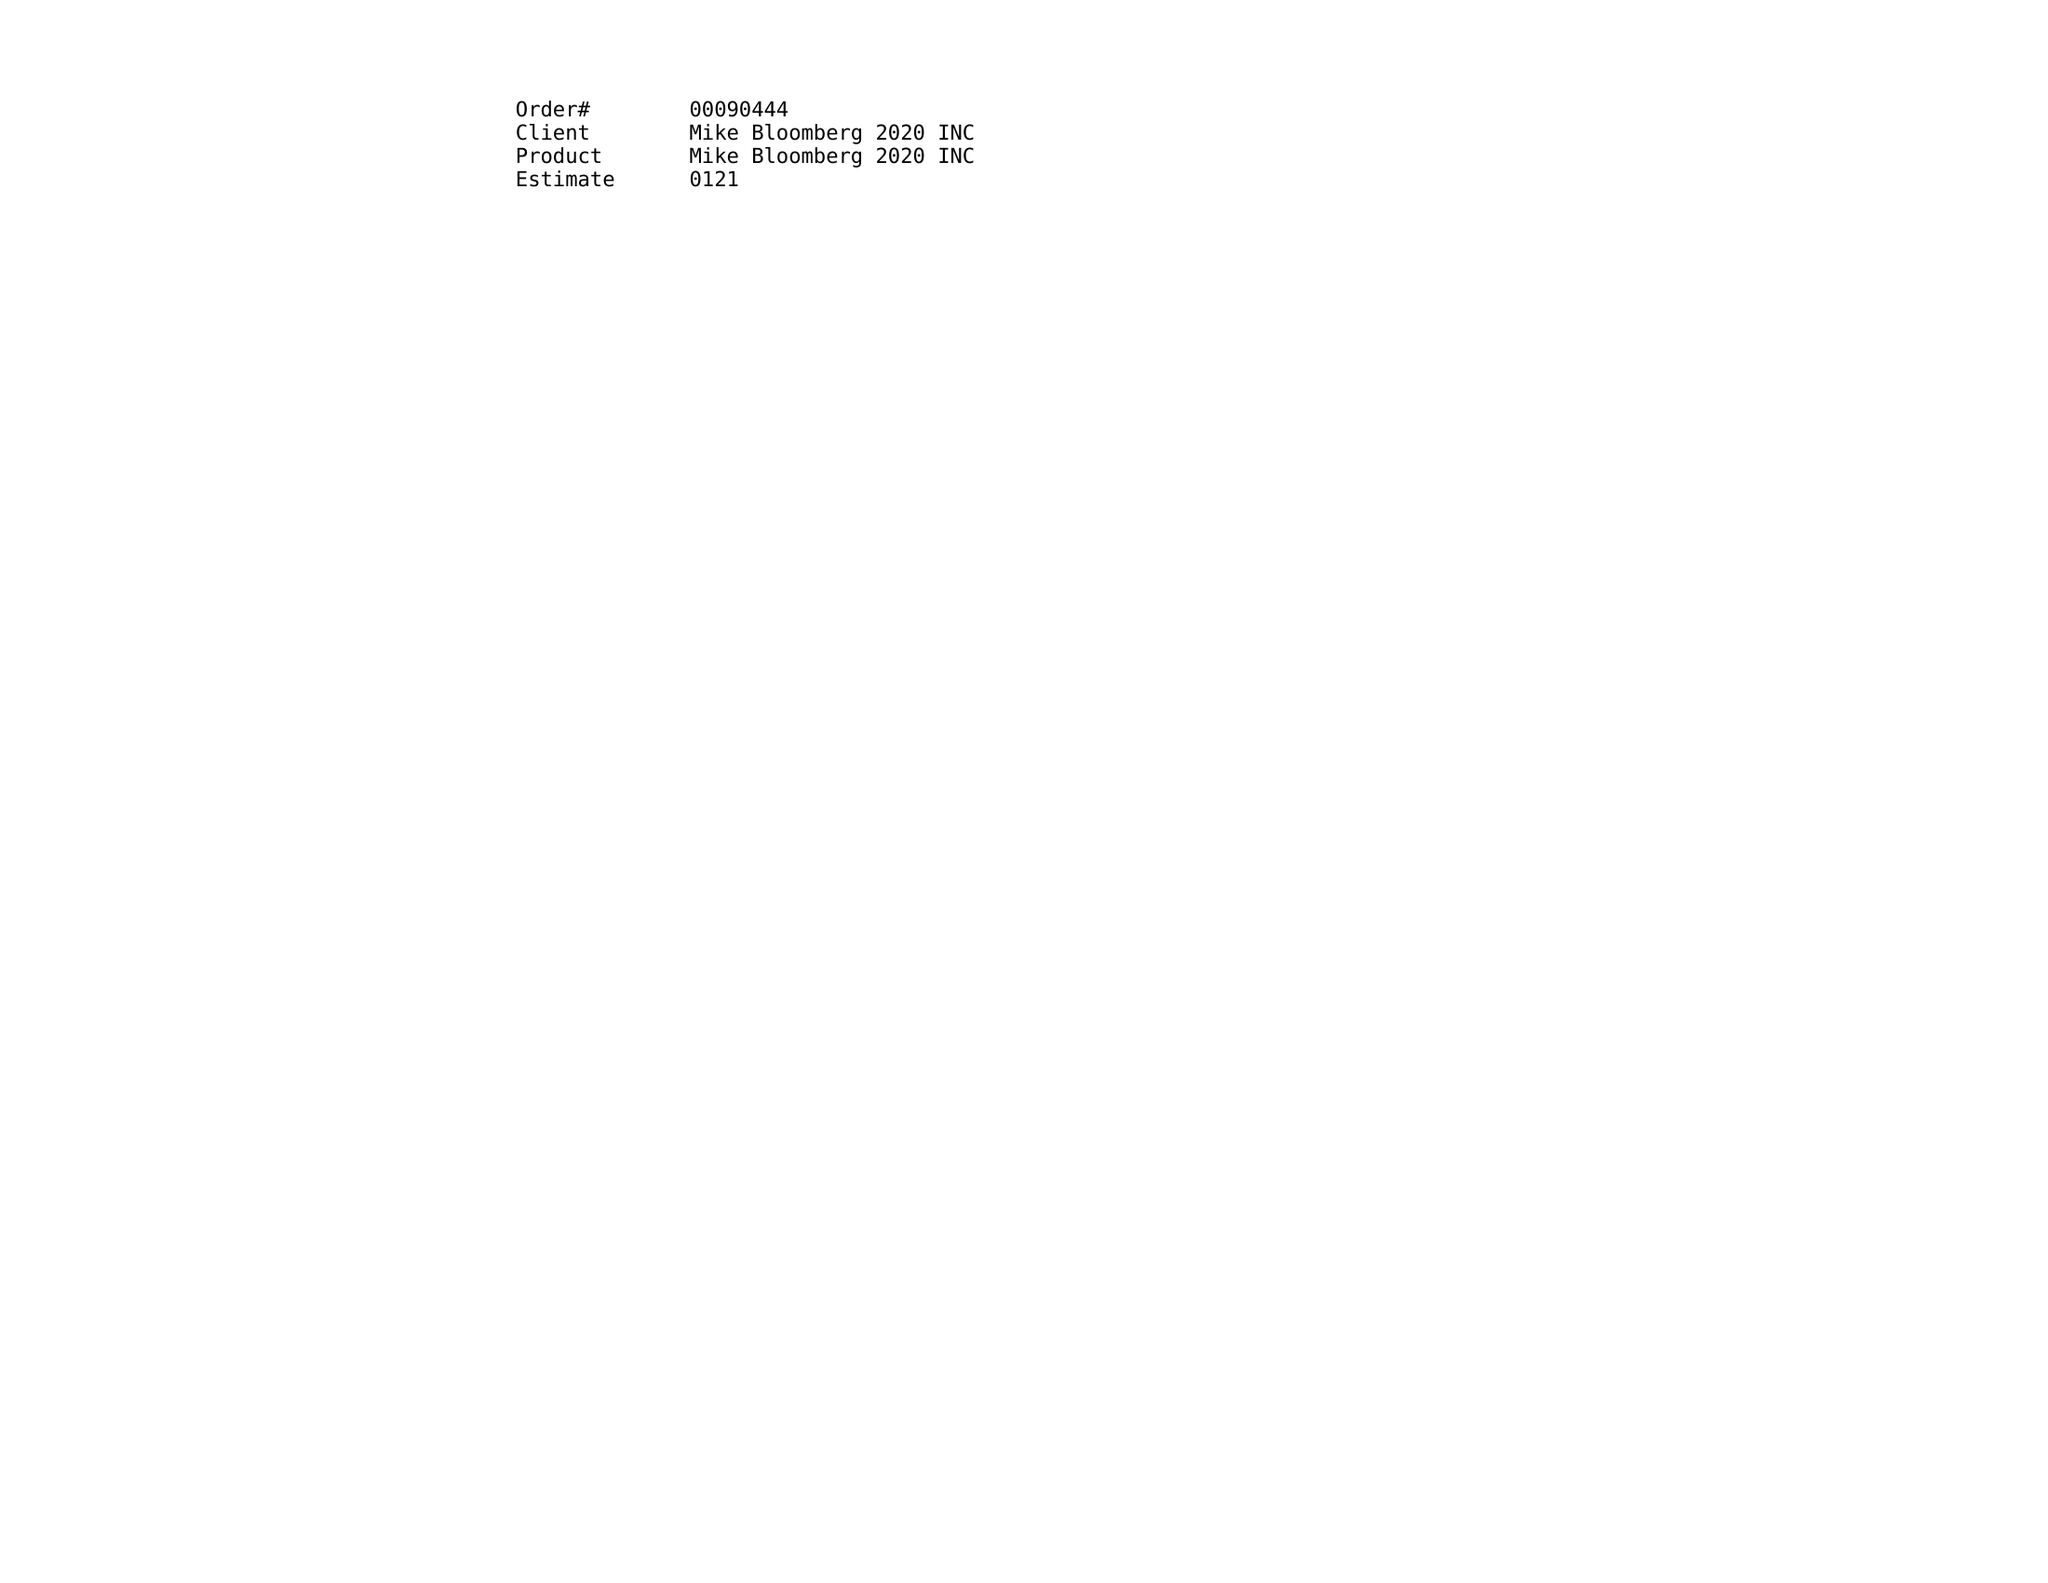What is the value for the contract_num?
Answer the question using a single word or phrase. 00090444 